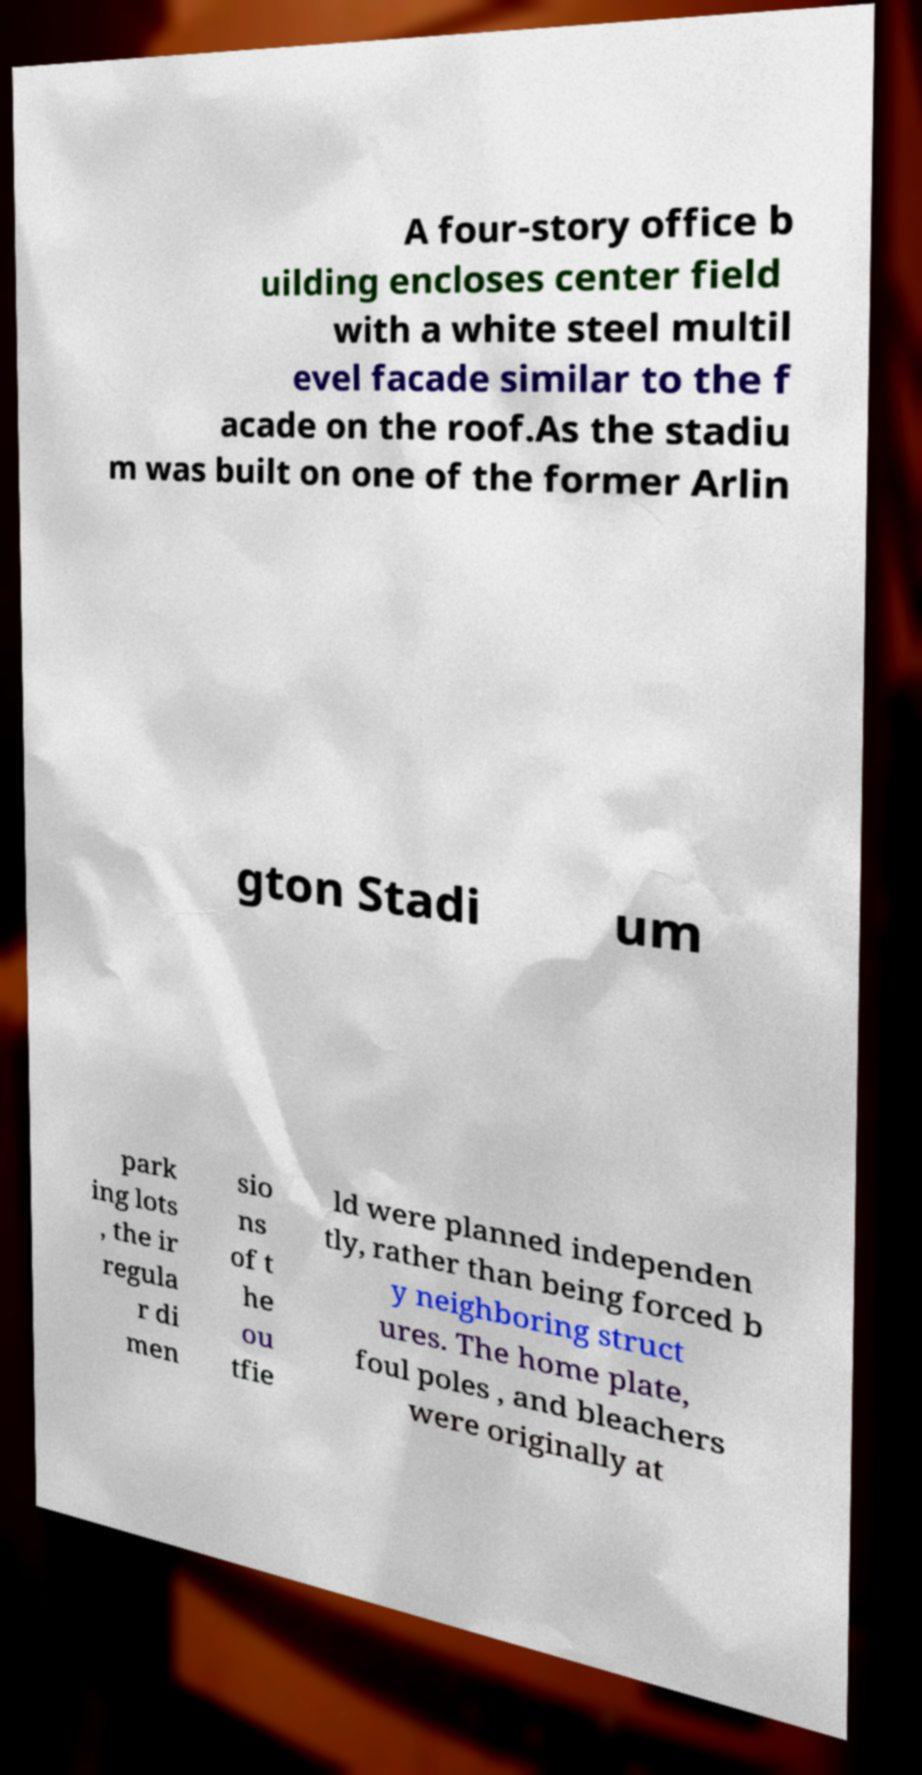What messages or text are displayed in this image? I need them in a readable, typed format. A four-story office b uilding encloses center field with a white steel multil evel facade similar to the f acade on the roof.As the stadiu m was built on one of the former Arlin gton Stadi um park ing lots , the ir regula r di men sio ns of t he ou tfie ld were planned independen tly, rather than being forced b y neighboring struct ures. The home plate, foul poles , and bleachers were originally at 